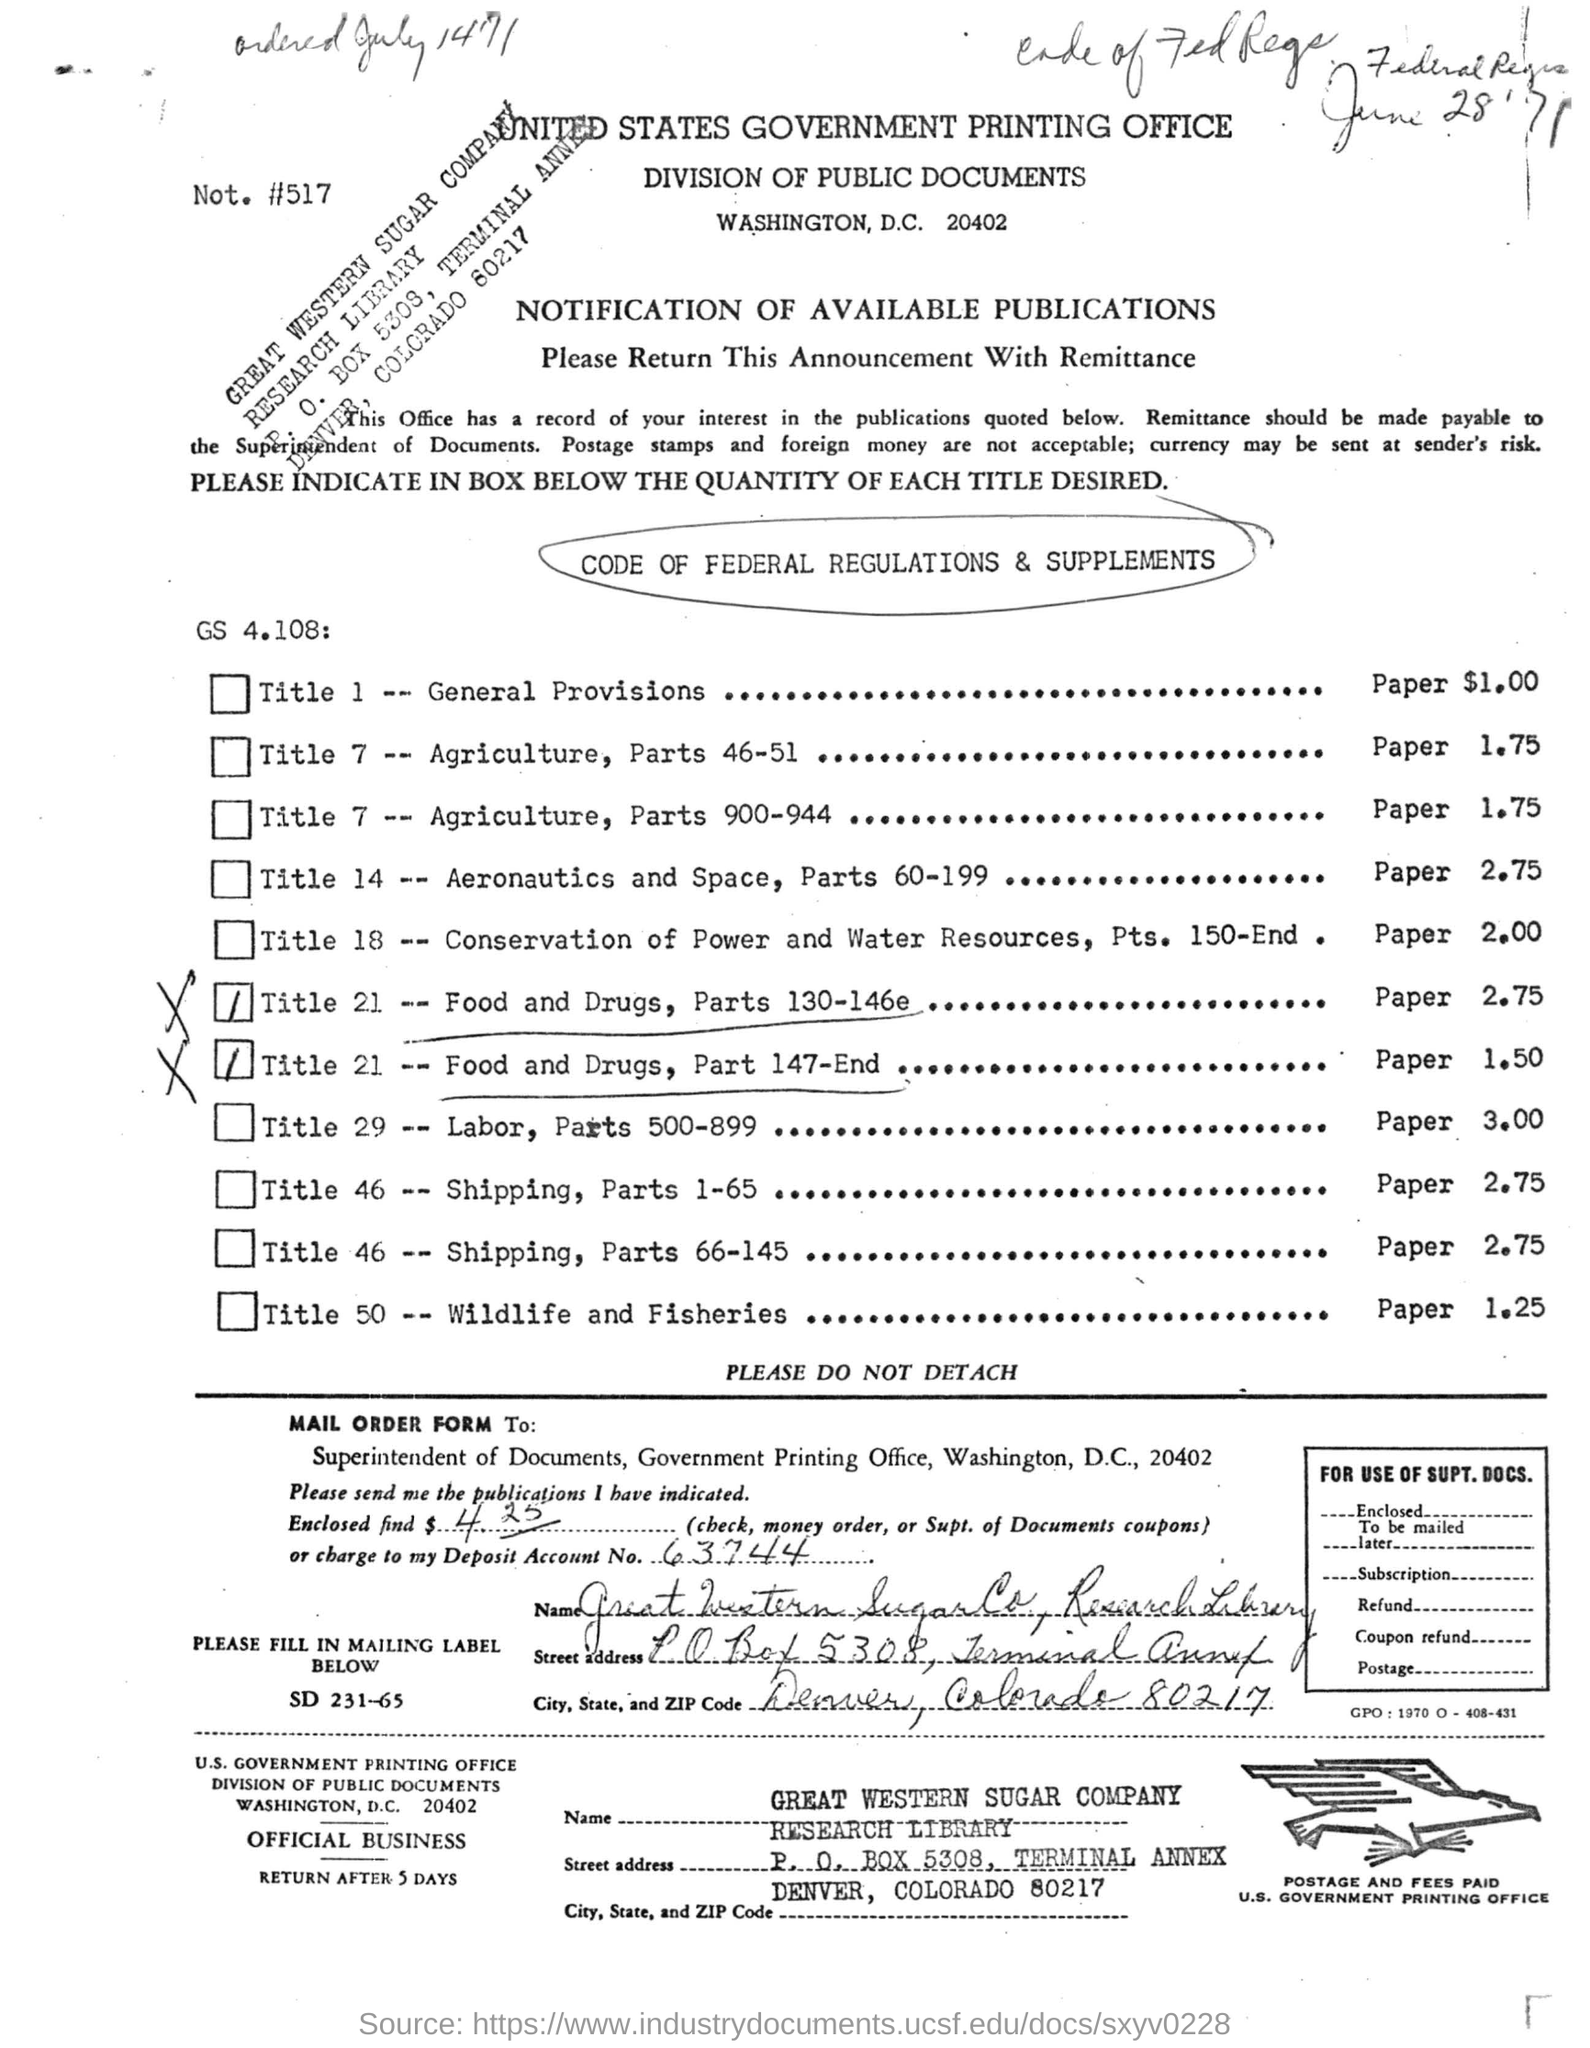Specify some key components in this picture. The MAIL ORDER FORM is intended for the Superintendent of Documents. The deposit account number mentioned is 63744... The United States Government Printing Office is the printing office mentioned in the letterhead. The mailing label mentions the state of Colorado. The mailing form is expected to return after 5 days. 